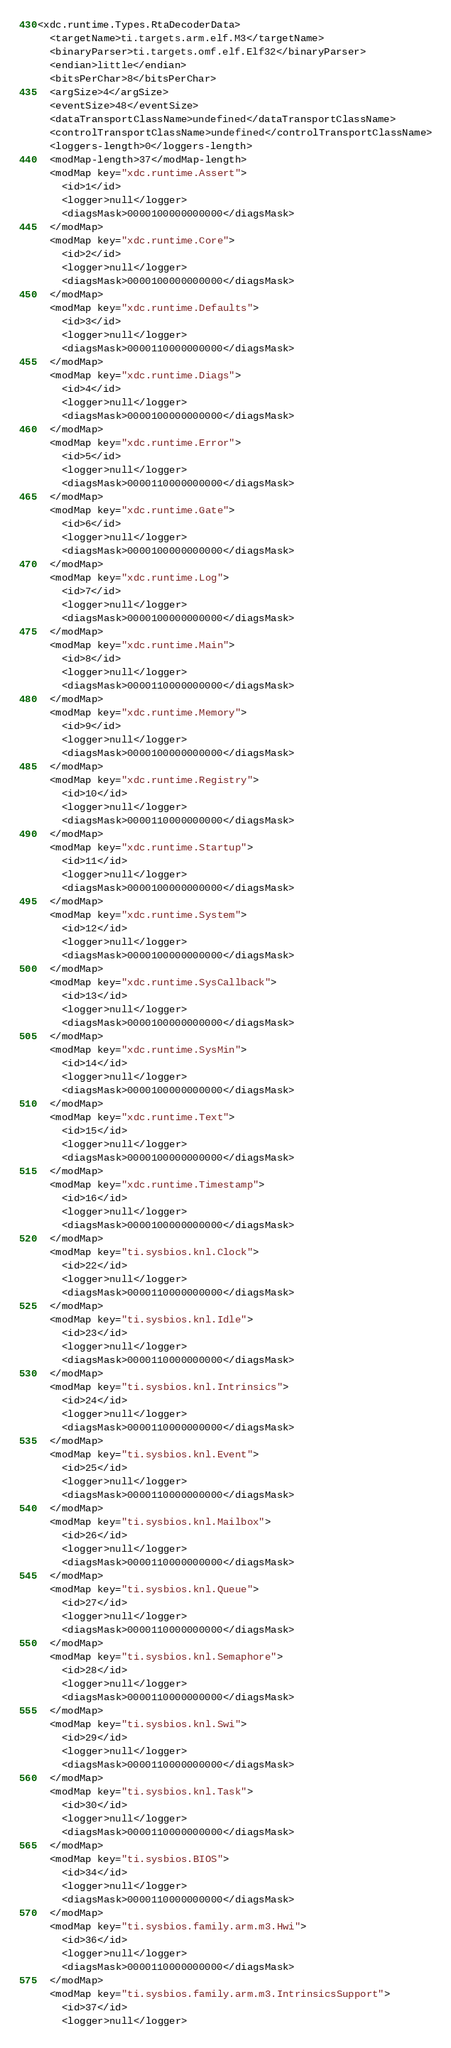<code> <loc_0><loc_0><loc_500><loc_500><_XML_><xdc.runtime.Types.RtaDecoderData>
  <targetName>ti.targets.arm.elf.M3</targetName>
  <binaryParser>ti.targets.omf.elf.Elf32</binaryParser>
  <endian>little</endian>
  <bitsPerChar>8</bitsPerChar>
  <argSize>4</argSize>
  <eventSize>48</eventSize>
  <dataTransportClassName>undefined</dataTransportClassName>
  <controlTransportClassName>undefined</controlTransportClassName>
  <loggers-length>0</loggers-length>
  <modMap-length>37</modMap-length>
  <modMap key="xdc.runtime.Assert">
    <id>1</id>
    <logger>null</logger>
    <diagsMask>0000100000000000</diagsMask>
  </modMap>
  <modMap key="xdc.runtime.Core">
    <id>2</id>
    <logger>null</logger>
    <diagsMask>0000100000000000</diagsMask>
  </modMap>
  <modMap key="xdc.runtime.Defaults">
    <id>3</id>
    <logger>null</logger>
    <diagsMask>0000110000000000</diagsMask>
  </modMap>
  <modMap key="xdc.runtime.Diags">
    <id>4</id>
    <logger>null</logger>
    <diagsMask>0000100000000000</diagsMask>
  </modMap>
  <modMap key="xdc.runtime.Error">
    <id>5</id>
    <logger>null</logger>
    <diagsMask>0000110000000000</diagsMask>
  </modMap>
  <modMap key="xdc.runtime.Gate">
    <id>6</id>
    <logger>null</logger>
    <diagsMask>0000100000000000</diagsMask>
  </modMap>
  <modMap key="xdc.runtime.Log">
    <id>7</id>
    <logger>null</logger>
    <diagsMask>0000100000000000</diagsMask>
  </modMap>
  <modMap key="xdc.runtime.Main">
    <id>8</id>
    <logger>null</logger>
    <diagsMask>0000110000000000</diagsMask>
  </modMap>
  <modMap key="xdc.runtime.Memory">
    <id>9</id>
    <logger>null</logger>
    <diagsMask>0000100000000000</diagsMask>
  </modMap>
  <modMap key="xdc.runtime.Registry">
    <id>10</id>
    <logger>null</logger>
    <diagsMask>0000110000000000</diagsMask>
  </modMap>
  <modMap key="xdc.runtime.Startup">
    <id>11</id>
    <logger>null</logger>
    <diagsMask>0000100000000000</diagsMask>
  </modMap>
  <modMap key="xdc.runtime.System">
    <id>12</id>
    <logger>null</logger>
    <diagsMask>0000100000000000</diagsMask>
  </modMap>
  <modMap key="xdc.runtime.SysCallback">
    <id>13</id>
    <logger>null</logger>
    <diagsMask>0000100000000000</diagsMask>
  </modMap>
  <modMap key="xdc.runtime.SysMin">
    <id>14</id>
    <logger>null</logger>
    <diagsMask>0000100000000000</diagsMask>
  </modMap>
  <modMap key="xdc.runtime.Text">
    <id>15</id>
    <logger>null</logger>
    <diagsMask>0000100000000000</diagsMask>
  </modMap>
  <modMap key="xdc.runtime.Timestamp">
    <id>16</id>
    <logger>null</logger>
    <diagsMask>0000100000000000</diagsMask>
  </modMap>
  <modMap key="ti.sysbios.knl.Clock">
    <id>22</id>
    <logger>null</logger>
    <diagsMask>0000110000000000</diagsMask>
  </modMap>
  <modMap key="ti.sysbios.knl.Idle">
    <id>23</id>
    <logger>null</logger>
    <diagsMask>0000110000000000</diagsMask>
  </modMap>
  <modMap key="ti.sysbios.knl.Intrinsics">
    <id>24</id>
    <logger>null</logger>
    <diagsMask>0000110000000000</diagsMask>
  </modMap>
  <modMap key="ti.sysbios.knl.Event">
    <id>25</id>
    <logger>null</logger>
    <diagsMask>0000110000000000</diagsMask>
  </modMap>
  <modMap key="ti.sysbios.knl.Mailbox">
    <id>26</id>
    <logger>null</logger>
    <diagsMask>0000110000000000</diagsMask>
  </modMap>
  <modMap key="ti.sysbios.knl.Queue">
    <id>27</id>
    <logger>null</logger>
    <diagsMask>0000110000000000</diagsMask>
  </modMap>
  <modMap key="ti.sysbios.knl.Semaphore">
    <id>28</id>
    <logger>null</logger>
    <diagsMask>0000110000000000</diagsMask>
  </modMap>
  <modMap key="ti.sysbios.knl.Swi">
    <id>29</id>
    <logger>null</logger>
    <diagsMask>0000110000000000</diagsMask>
  </modMap>
  <modMap key="ti.sysbios.knl.Task">
    <id>30</id>
    <logger>null</logger>
    <diagsMask>0000110000000000</diagsMask>
  </modMap>
  <modMap key="ti.sysbios.BIOS">
    <id>34</id>
    <logger>null</logger>
    <diagsMask>0000110000000000</diagsMask>
  </modMap>
  <modMap key="ti.sysbios.family.arm.m3.Hwi">
    <id>36</id>
    <logger>null</logger>
    <diagsMask>0000110000000000</diagsMask>
  </modMap>
  <modMap key="ti.sysbios.family.arm.m3.IntrinsicsSupport">
    <id>37</id>
    <logger>null</logger></code> 